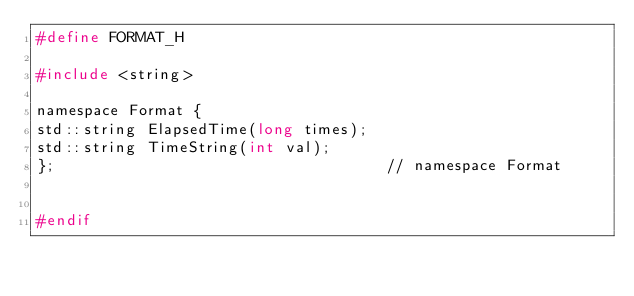Convert code to text. <code><loc_0><loc_0><loc_500><loc_500><_C_>#define FORMAT_H

#include <string>

namespace Format {
std::string ElapsedTime(long times);
std::string TimeString(int val);
};                                    // namespace Format


#endif</code> 